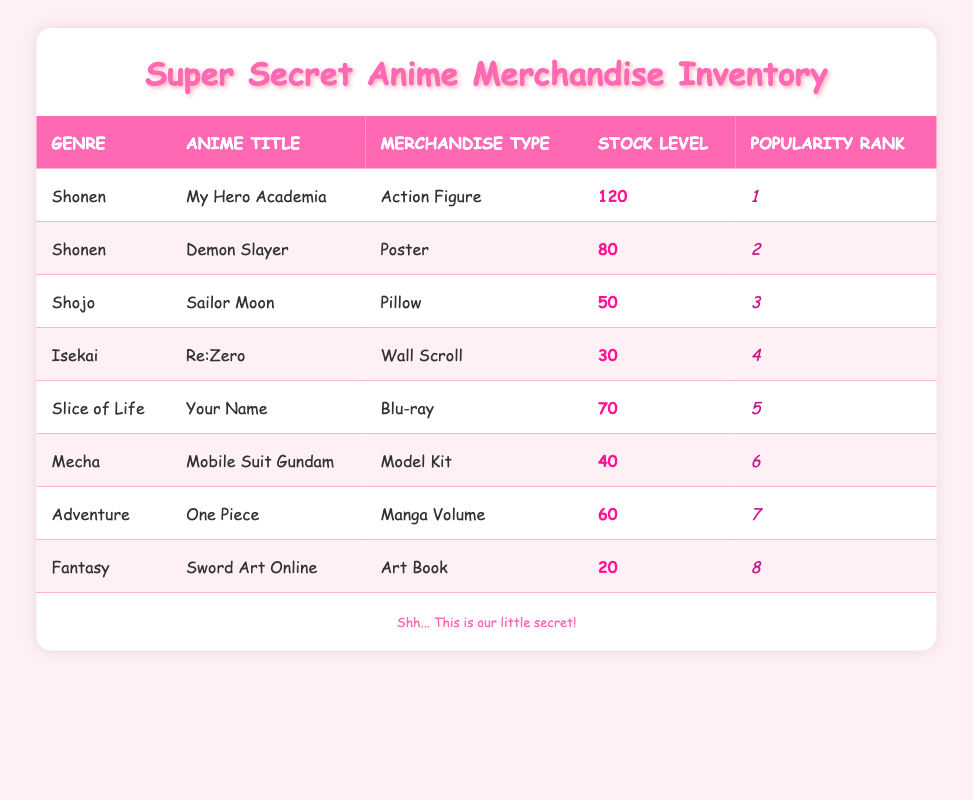What is the stock level of "My Hero Academia"? The stock level for "My Hero Academia" is explicitly listed in the table under the stock level column for that title, which shows the stock level as 120.
Answer: 120 Which merchandise type is most popular in the Shonen genre? In the Shonen genre, "My Hero Academia" has the highest popularity rank of 1, and its merchandise type is an Action Figure. Therefore, this item is the most popular in the Shonen genre.
Answer: Action Figure How many items are in stock for "Sword Art Online"? The stock level for "Sword Art Online" is specifically mentioned under the stock level column, which indicates that there are 20 items in stock for this title.
Answer: 20 What is the total stock level of all merchandise types combined? To find the total stock level, we sum up all the stock levels listed in the table: 120 + 80 + 50 + 30 + 70 + 40 + 60 + 20 = 470. Therefore, the total stock level is 470.
Answer: 470 Is there a merchandise type with a stock level of 50? By checking each merchandise type in the stock level column, we can see that the stock level of "Sailor Moon" is 50. Thus, there is indeed a merchandise type with this stock level.
Answer: Yes Which anime title has the lowest stock level? Among all the stock levels visible in the table, "Sword Art Online" has the lowest stock level at 20. We compare each stock level and confirm that it is the least value.
Answer: Sword Art Online How many more stock levels does "My Hero Academia" have compared to "Re:Zero"? The stock level of "My Hero Academia" is 120, while "Re:Zero" has a stock level of 30. The difference here is 120 - 30 = 90. Therefore, "My Hero Academia" has 90 more in stock.
Answer: 90 Which genre has the highest stock level, and what is that stock level? After reviewing all stock levels by genre, Shonen (specifically "My Hero Academia") is the highest with 120. We confirm by checking all entries.
Answer: Shonen, 120 How many merchandise types have a stock level above 50? The stock levels above 50 are for "My Hero Academia" (120), "Demon Slayer" (80), and "Your Name" (70). Counting these gives us three merchandise types total that exceed the specified stock level.
Answer: 3 